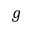<formula> <loc_0><loc_0><loc_500><loc_500>g</formula> 